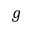<formula> <loc_0><loc_0><loc_500><loc_500>g</formula> 